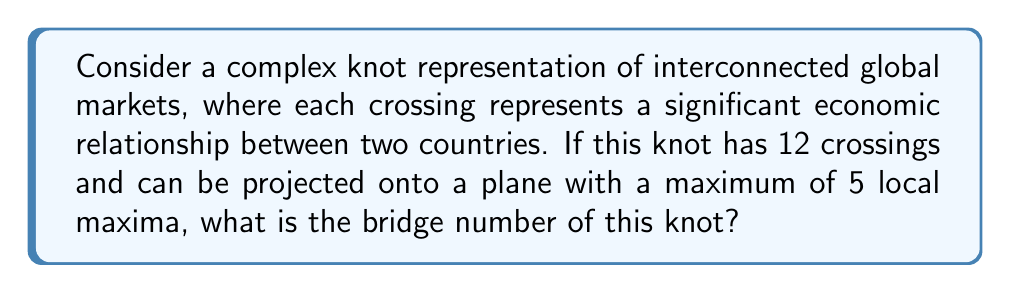Give your solution to this math problem. To solve this problem, we need to understand the concept of bridge number and its relation to the knot's projection:

1) The bridge number of a knot is defined as the minimum number of local maxima over all possible projections of the knot onto a plane.

2) In this case, we're given that the knot can be projected with a maximum of 5 local maxima. This means that the bridge number is at most 5.

3) However, we need to consider if it's possible to have a projection with fewer local maxima.

4) Given that the knot has 12 crossings, it's likely to be quite complex. The number of crossings often correlates with the minimum number of bridges needed.

5) For a knot with 12 crossings, it's highly unlikely to have a bridge number less than 4, as that would imply an unusually simple structure for a knot with so many crossings.

6) Therefore, the bridge number is either 4 or 5.

7) Without more specific information about the knot's structure, we can't determine if a 4-bridge projection exists.

8) Thus, based on the given information, the best we can say is that the bridge number is at most 5.

In the context of interconnected global markets, this bridge number suggests a high degree of complexity and interconnectedness, with at least 5 major "peaks" or dominant market forces influencing the overall economic landscape.
Answer: $\leq 5$ 